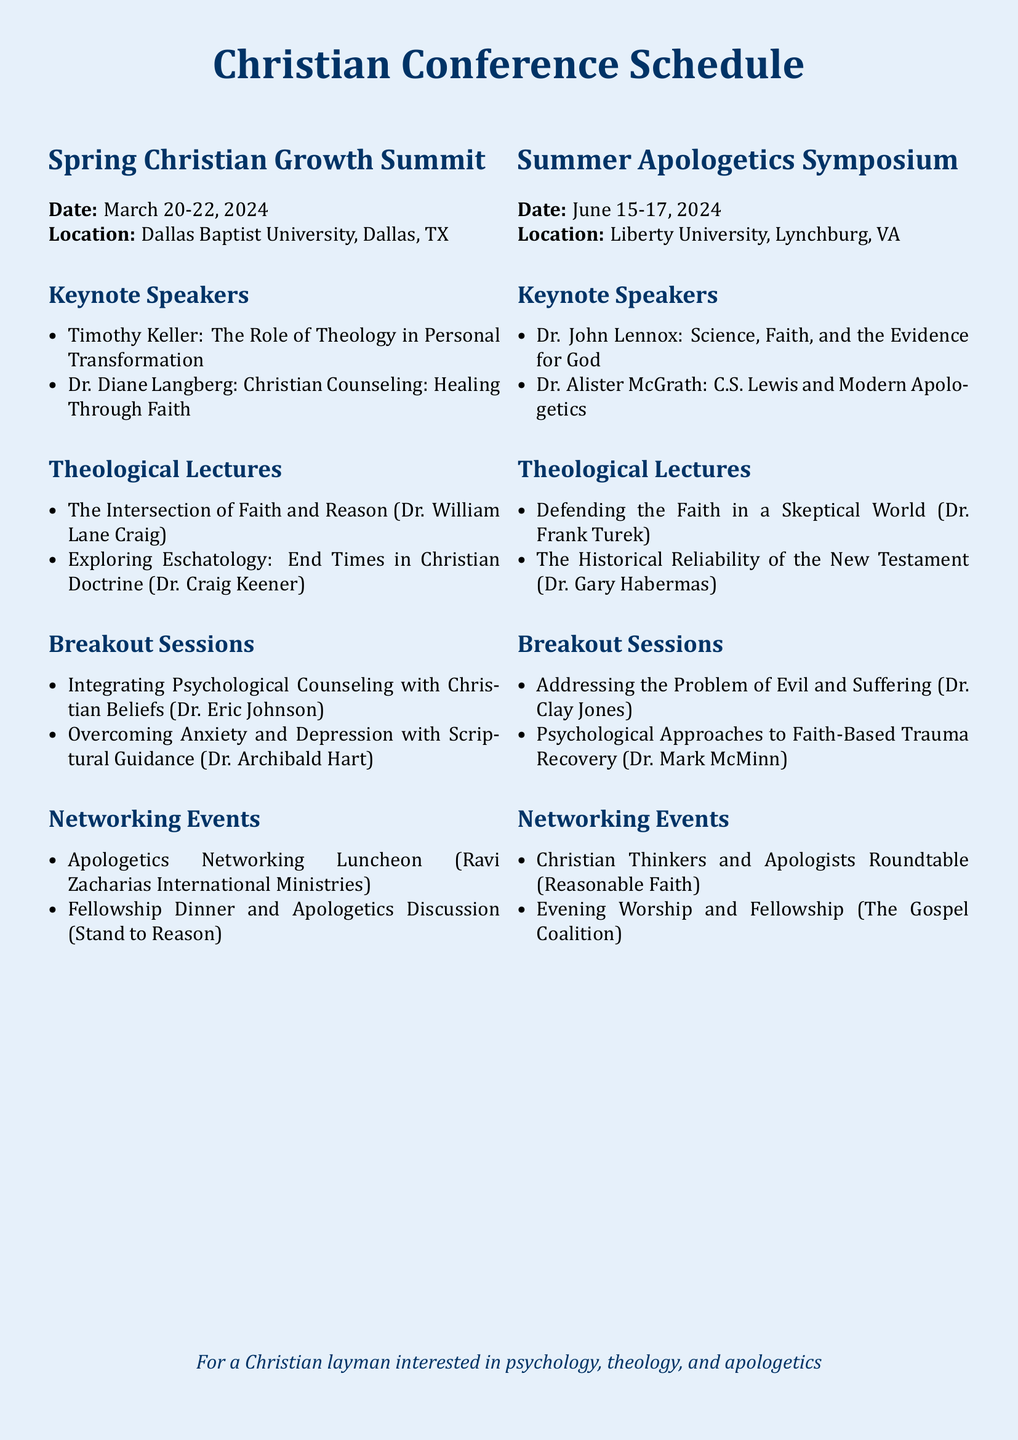What are the dates for the Spring Christian Growth Summit? The dates for the Spring Christian Growth Summit are clearly stated in the document as March 20-22, 2024.
Answer: March 20-22, 2024 Who is the keynote speaker discussing the intersection of faith and reason? The document lists Dr. William Lane Craig as the speaker for the lecture on the intersection of faith and reason.
Answer: Dr. William Lane Craig What is the location of the Summer Apologetics Symposium? The document specifies Liberty University, Lynchburg, VA as the location for the Summer Apologetics Symposium.
Answer: Liberty University, Lynchburg, VA How many keynote speakers are present at the Spring Christian Growth Summit? The document mentions there are two keynote speakers listed under the Spring Christian Growth Summit section.
Answer: 2 Which breakout session addresses the problem of evil and suffering? The document identifies "Addressing the Problem of Evil and Suffering" as a breakout session at the Summer Apologetics Symposium.
Answer: Addressing the Problem of Evil and Suffering What organization is hosting the Apologetics Networking Luncheon? The document attributes the Apologetics Networking Luncheon to Ravi Zacharias International Ministries.
Answer: Ravi Zacharias International Ministries What is the theme of Dr. John Lennox's keynote address? The theme of Dr. John Lennox's keynote address is focused on "Science, Faith, and the Evidence for God," as stated in the schedule.
Answer: Science, Faith, and the Evidence for God What type of event is the Fellowship Dinner? The document categorizes the Fellowship Dinner as a networking event that facilitates discussion on apologetics.
Answer: Networking event Which lecture discusses the historical reliability of the New Testament? The document states that Dr. Gary Habermas presents a lecture on "The Historical Reliability of the New Testament."
Answer: The Historical Reliability of the New Testament 